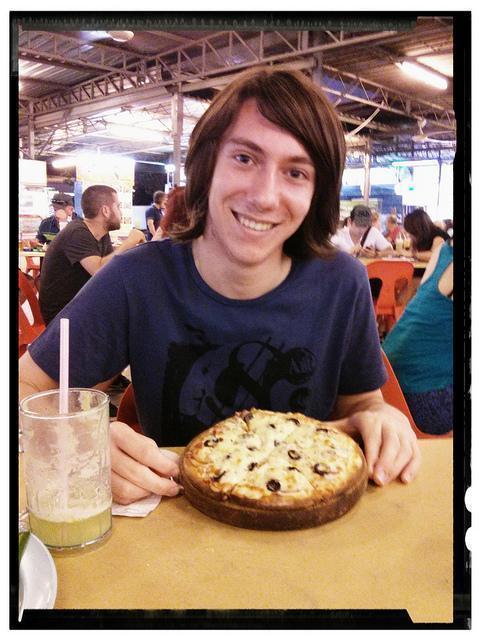What type of crust is this called?
From the following four choices, select the correct answer to address the question.
Options: Cheese, grilled, thin, thick. Thick. 